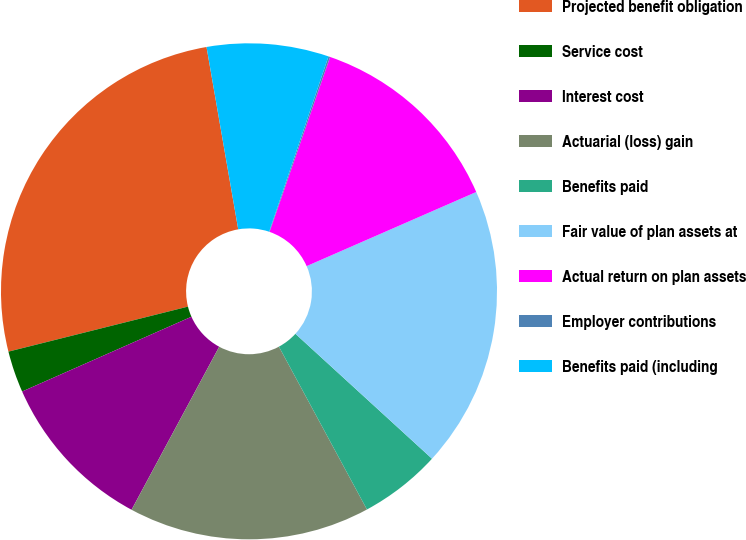Convert chart. <chart><loc_0><loc_0><loc_500><loc_500><pie_chart><fcel>Projected benefit obligation<fcel>Service cost<fcel>Interest cost<fcel>Actuarial (loss) gain<fcel>Benefits paid<fcel>Fair value of plan assets at<fcel>Actual return on plan assets<fcel>Employer contributions<fcel>Benefits paid (including<nl><fcel>26.17%<fcel>2.71%<fcel>10.53%<fcel>15.74%<fcel>5.32%<fcel>18.35%<fcel>13.14%<fcel>0.11%<fcel>7.93%<nl></chart> 